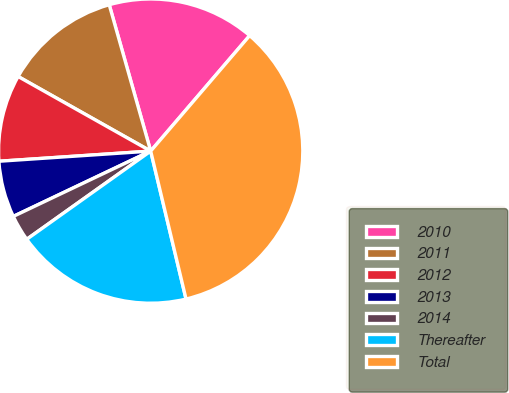<chart> <loc_0><loc_0><loc_500><loc_500><pie_chart><fcel>2010<fcel>2011<fcel>2012<fcel>2013<fcel>2014<fcel>Thereafter<fcel>Total<nl><fcel>15.67%<fcel>12.45%<fcel>9.22%<fcel>6.0%<fcel>2.78%<fcel>18.89%<fcel>34.99%<nl></chart> 